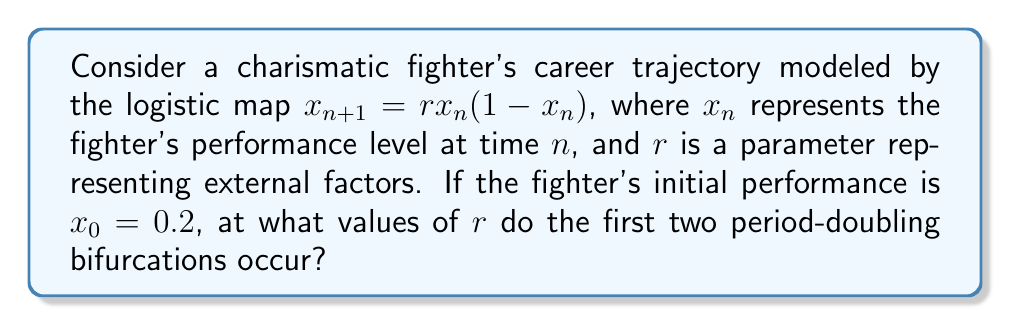Solve this math problem. To determine the bifurcation points in the fighter's career trajectory using chaos theory principles, we'll follow these steps:

1) The logistic map $x_{n+1} = rx_n(1-x_n)$ is a classic example in chaos theory. For our charismatic fighter, this could represent how their performance evolves over time, influenced by factors like training, competition, and publicity.

2) Bifurcation points occur when the behavior of the system changes qualitatively. In the logistic map, these occur at specific values of $r$.

3) The first bifurcation occurs when the system transitions from a stable fixed point to a period-2 cycle. This happens at $r_1 = 3$.

4) To find the second bifurcation point, we need to solve the equation:

   $$r^2 - 2r - 3 = 0$$

5) Using the quadratic formula:

   $$r = \frac{2 \pm \sqrt{4 + 12}}{2} = 1 \pm \sqrt{4} = 1 \pm 2$$

6) The positive solution gives us the second bifurcation point:

   $$r_2 = 1 + 2 = 3.449489742...$$

   This is where the period-2 cycle splits into a period-4 cycle.

7) These bifurcation points represent critical junctures in the fighter's career where small changes in external factors can lead to dramatically different outcomes, much like how a trash-talking moment or a showboating display might unexpectedly alter the course of a fight.
Answer: $r_1 = 3$, $r_2 \approx 3.449489742$ 